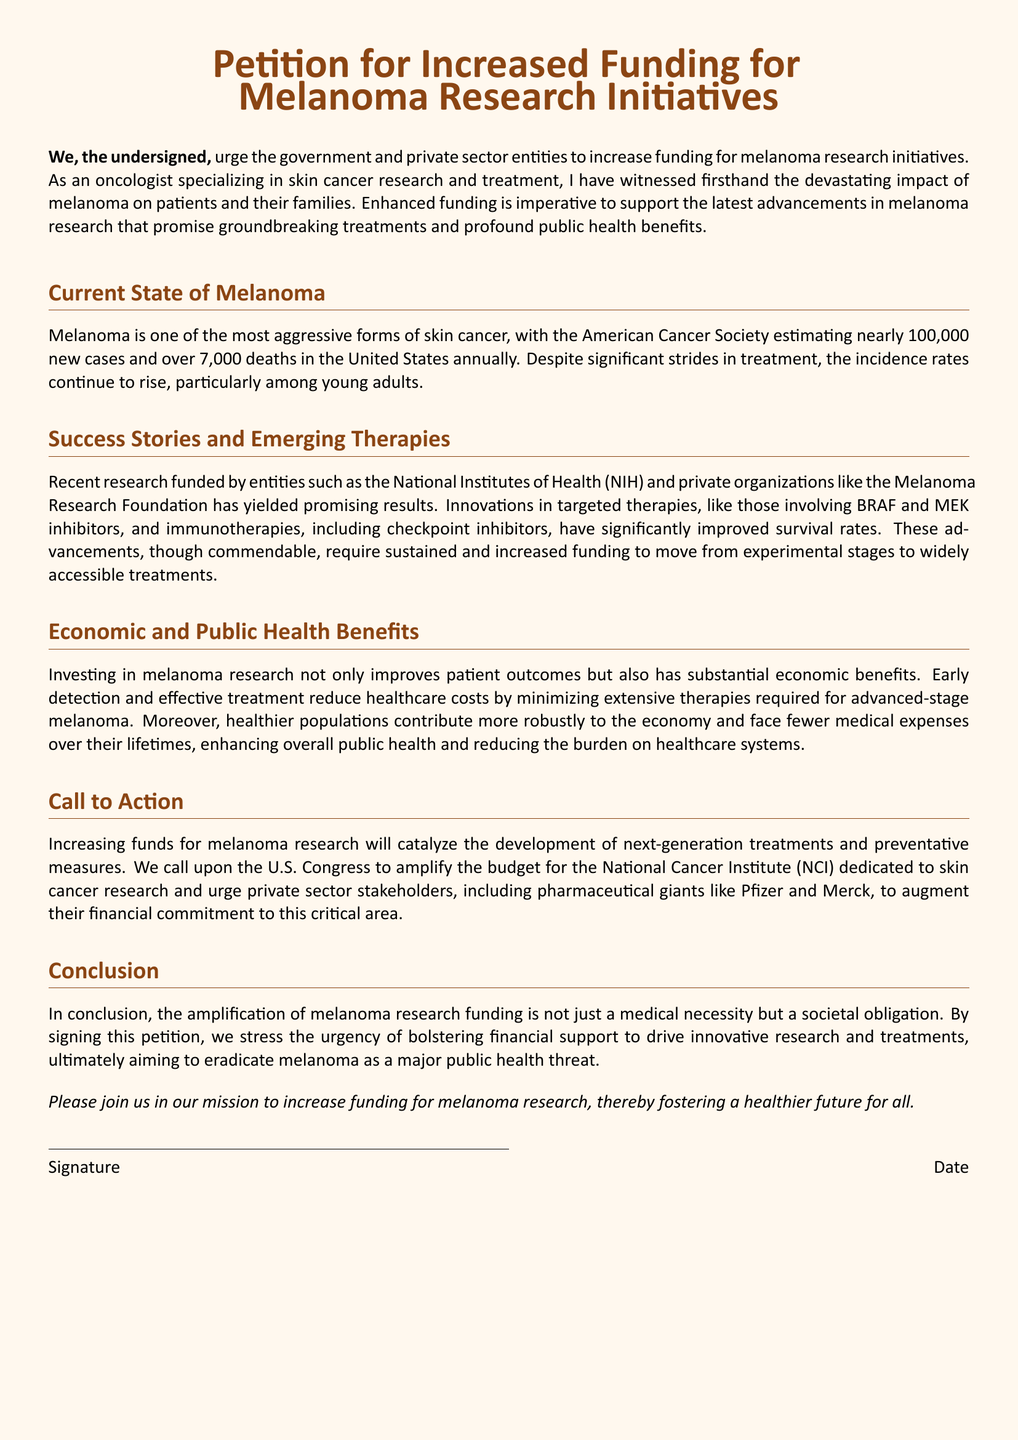What is the main focus of the petition? The main focus of the petition is to urge for increased funding for melanoma research initiatives.
Answer: Increased funding for melanoma research initiatives How many new cases of melanoma are estimated annually in the U.S.? The document states that nearly 100,000 new cases of melanoma are estimated annually in the U.S.
Answer: Nearly 100,000 What are the two types of therapies mentioned in the success stories? The therapies mentioned are targeted therapies and immunotherapies.
Answer: Targeted therapies and immunotherapies What organization is highlighted for funding melanoma research? The document highlights the National Institutes of Health (NIH) for funding melanoma research.
Answer: National Institutes of Health (NIH) What is the estimated number of deaths from melanoma annually in the U.S.? The estimated number of deaths from melanoma annually in the U.S. is over 7,000.
Answer: Over 7,000 What benefits does investing in melanoma research provide? Investing in melanoma research provides both improved patient outcomes and substantial economic benefits.
Answer: Improved patient outcomes and substantial economic benefits What is the call to action regarding funding? The call to action is to amplify the budget for the National Cancer Institute (NCI) dedicated to skin cancer research.
Answer: Amplify the budget for the National Cancer Institute (NCI) Why is increased funding deemed a societal obligation? Increased funding is considered a societal obligation to drive innovative research and treatments.
Answer: To drive innovative research and treatments 